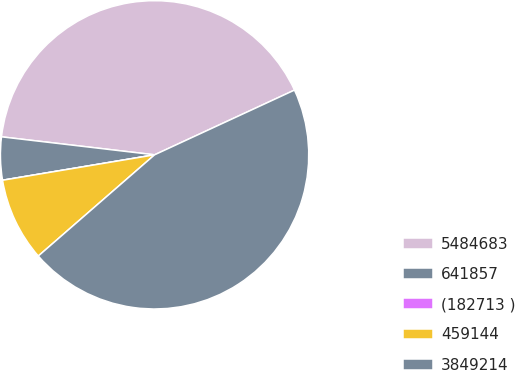Convert chart to OTSL. <chart><loc_0><loc_0><loc_500><loc_500><pie_chart><fcel>5484683<fcel>641857<fcel>(182713 )<fcel>459144<fcel>3849214<nl><fcel>41.24%<fcel>4.5%<fcel>0.0%<fcel>8.76%<fcel>45.5%<nl></chart> 